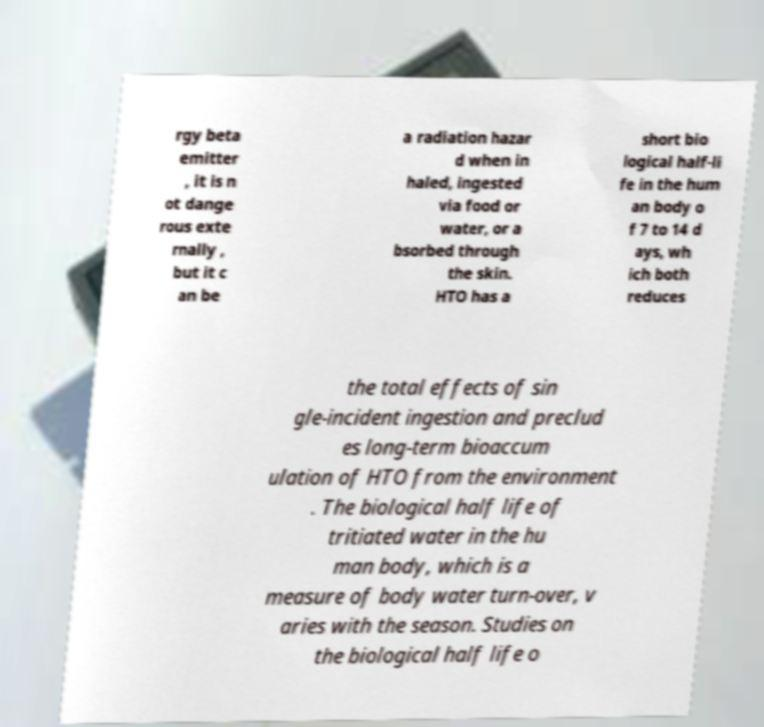Can you accurately transcribe the text from the provided image for me? rgy beta emitter , it is n ot dange rous exte rnally , but it c an be a radiation hazar d when in haled, ingested via food or water, or a bsorbed through the skin. HTO has a short bio logical half-li fe in the hum an body o f 7 to 14 d ays, wh ich both reduces the total effects of sin gle-incident ingestion and preclud es long-term bioaccum ulation of HTO from the environment . The biological half life of tritiated water in the hu man body, which is a measure of body water turn-over, v aries with the season. Studies on the biological half life o 